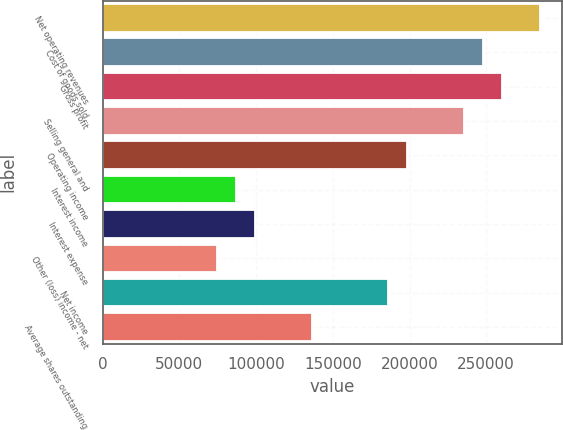Convert chart to OTSL. <chart><loc_0><loc_0><loc_500><loc_500><bar_chart><fcel>Net operating revenues<fcel>Cost of goods sold<fcel>Gross profit<fcel>Selling general and<fcel>Operating income<fcel>Interest income<fcel>Interest expense<fcel>Other (loss) income - net<fcel>Net income<fcel>Average shares outstanding<nl><fcel>284987<fcel>247815<fcel>260206<fcel>235424<fcel>198252<fcel>86735.9<fcel>99126.6<fcel>74345.1<fcel>185862<fcel>136299<nl></chart> 